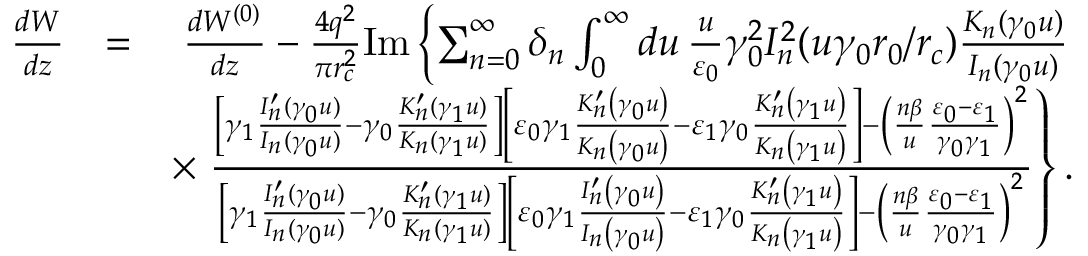Convert formula to latex. <formula><loc_0><loc_0><loc_500><loc_500>\begin{array} { r l r } { \frac { d W } { d z } } & { = } & { \frac { d W ^ { ( 0 ) } } { d z } - \frac { 4 q ^ { 2 } } { \pi r _ { c } ^ { 2 } } I m \left \{ \sum _ { n = 0 } ^ { \infty } \delta _ { n } \int _ { 0 } ^ { \infty } d u \, \frac { u } { \varepsilon _ { 0 } } \gamma _ { 0 } ^ { 2 } I _ { n } ^ { 2 } ( u \gamma _ { 0 } r _ { 0 } / r _ { c } ) \frac { K _ { n } ( \gamma _ { 0 } u ) } { I _ { n } ( \gamma _ { 0 } u ) } } \\ & { \times \frac { \left [ \gamma _ { 1 } \frac { I _ { n } ^ { \prime } ( \gamma _ { 0 } u ) } { I _ { n } ( \gamma _ { 0 } u ) } - \gamma _ { 0 } \frac { K _ { n } ^ { \prime } ( \gamma _ { 1 } u ) } { K _ { n } ( \gamma _ { 1 } u ) } \right ] \left [ \varepsilon _ { 0 } \gamma _ { 1 } \frac { K _ { n } ^ { \prime } \left ( \gamma _ { 0 } u \right ) } { K _ { n } \left ( \gamma _ { 0 } u \right ) } - \varepsilon _ { 1 } \gamma _ { 0 } \frac { K _ { n } ^ { \prime } \left ( \gamma _ { 1 } u \right ) } { K _ { n } \left ( \gamma _ { 1 } u \right ) } \right ] - \left ( \frac { n \beta } { u } \frac { \varepsilon _ { 0 } - \varepsilon _ { 1 } } { \gamma _ { 0 } \gamma _ { 1 } } \right ) ^ { 2 } } { \left [ \gamma _ { 1 } \frac { I _ { n } ^ { \prime } ( \gamma _ { 0 } u ) } { I _ { n } ( \gamma _ { 0 } u ) } - \gamma _ { 0 } \frac { K _ { n } ^ { \prime } ( \gamma _ { 1 } u ) } { K _ { n } ( \gamma _ { 1 } u ) } \right ] \left [ \varepsilon _ { 0 } \gamma _ { 1 } \frac { I _ { n } ^ { \prime } \left ( \gamma _ { 0 } u \right ) } { I _ { n } \left ( \gamma _ { 0 } u \right ) } - \varepsilon _ { 1 } \gamma _ { 0 } \frac { K _ { n } ^ { \prime } \left ( \gamma _ { 1 } u \right ) } { K _ { n } \left ( \gamma _ { 1 } u \right ) } \right ] - \left ( \frac { n \beta } { u } \frac { \varepsilon _ { 0 } - \varepsilon _ { 1 } } { \gamma _ { 0 } \gamma _ { 1 } } \right ) ^ { 2 } } \right \} . } \end{array}</formula> 